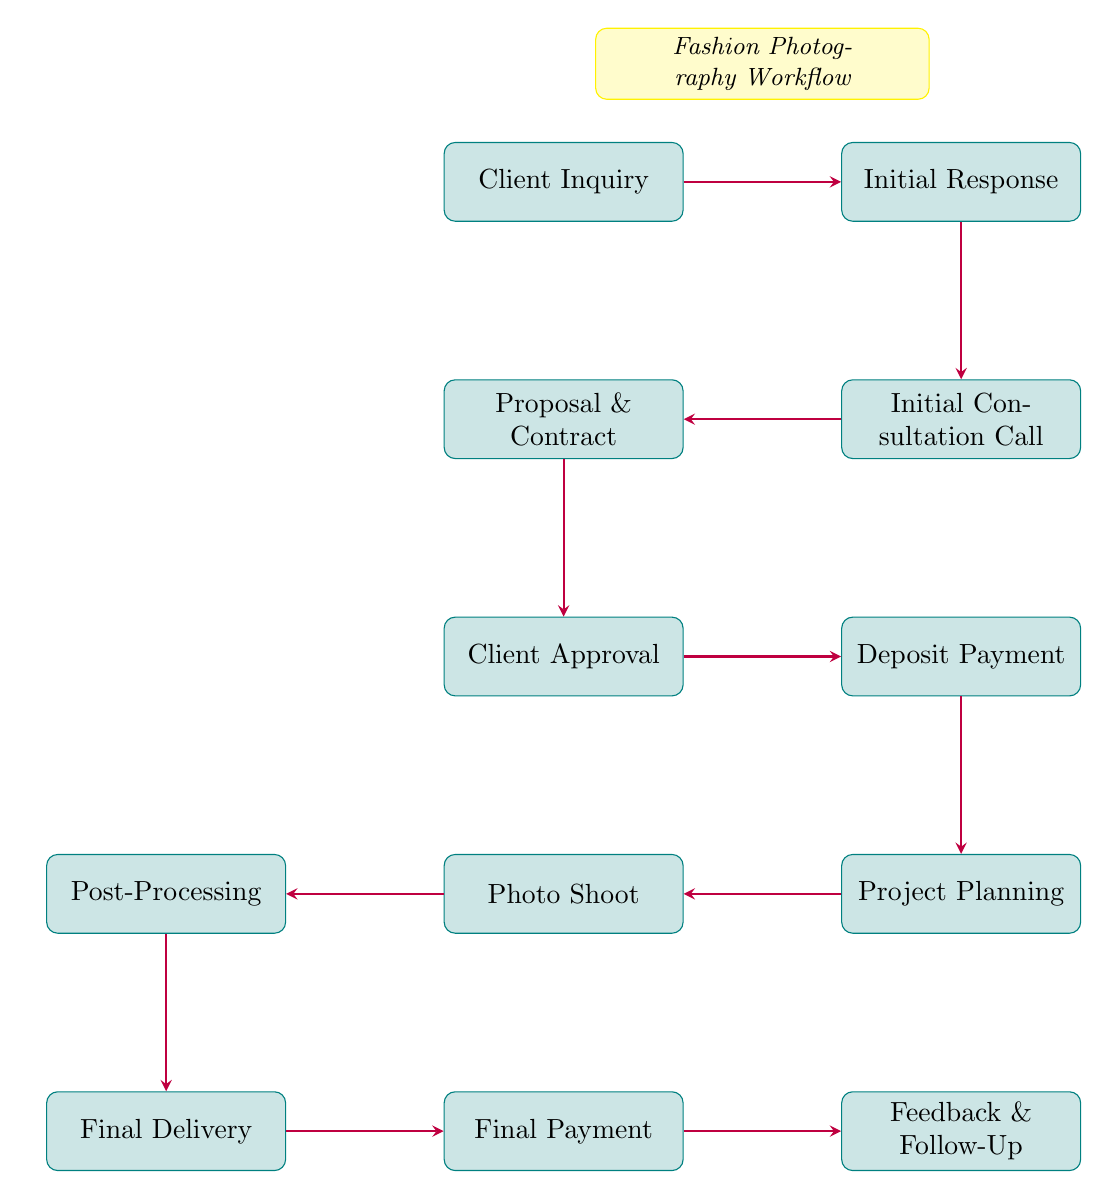What is the first step in the process? The first step in the process is labeled as "Client Inquiry". It is the starting node from which the flow begins.
Answer: Client Inquiry How many nodes are there in the diagram? By counting each labeled step or process in the flow chart, we find a total of 12 nodes.
Answer: 12 What comes after the "Initial Consultation Call"? The next step following "Initial Consultation Call" is "Proposal & Contract", which is directly connected in the flow.
Answer: Proposal & Contract What does the client do after reviewing the contract? After reviewing the contract, the client proceeds to either sign it or request modifications, leading to the "Client Approval" step.
Answer: Client Approval How many actions can the client take during the "Client Approval"? The client can take two actions: review and sign the contract, or request modifications. Therefore, there are two distinct actions.
Answer: Two actions Which step requires a payment? The "Deposit Payment" step requires payment from the client, making it a crucial part of the workflow that follows "Client Approval".
Answer: Deposit Payment What is involved in the "Project Planning" phase? During "Project Planning", the photographer schedules the shoot date and gathers necessary resources, including creating a mood board, casting models, and scouting locations.
Answer: Mood Board Creation, Casting Models, Location Scouting What happens before "Photo Shoot"? Before the "Photo Shoot" can occur, the "Project Planning" must take place, ensuring all resources and dates are set in place beforehand.
Answer: Project Planning What is the final step of the process according to the diagram? The final step outlined in the flow chart is labeled as "Feedback & Follow-Up", which concludes the workflow.
Answer: Feedback & Follow-Up 